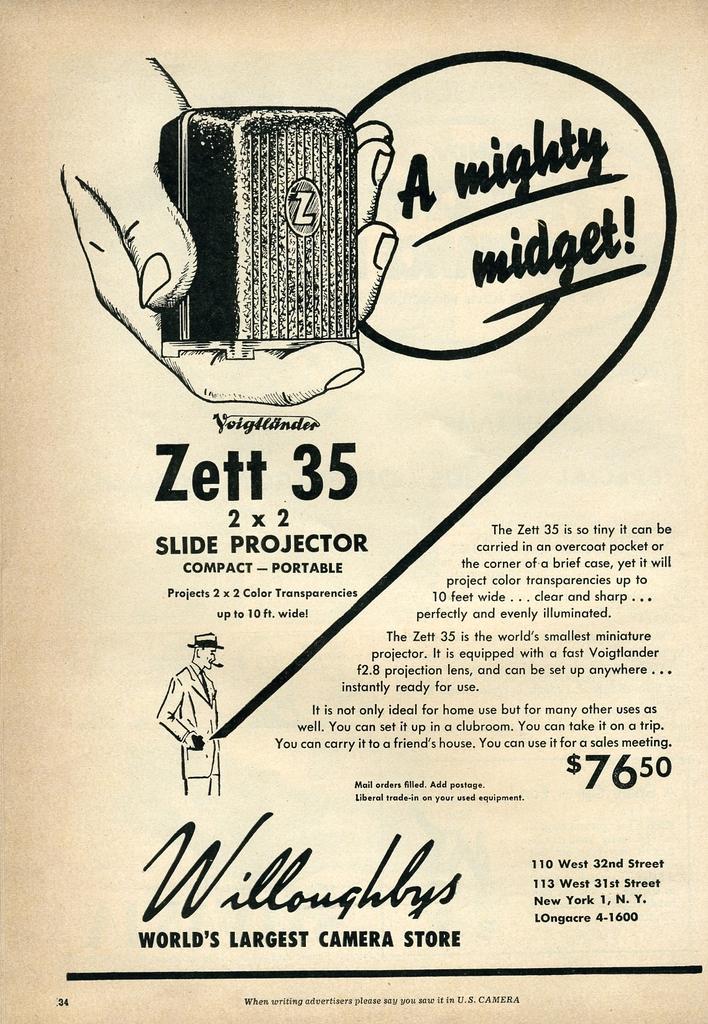Can you describe this image briefly? This is a picture of a poster. In this picture, we see the sketch of a man and the hand of a person who is holding an object. On the right side, we see some text written in black color. In the background, it is white in color and it might be a paper. 